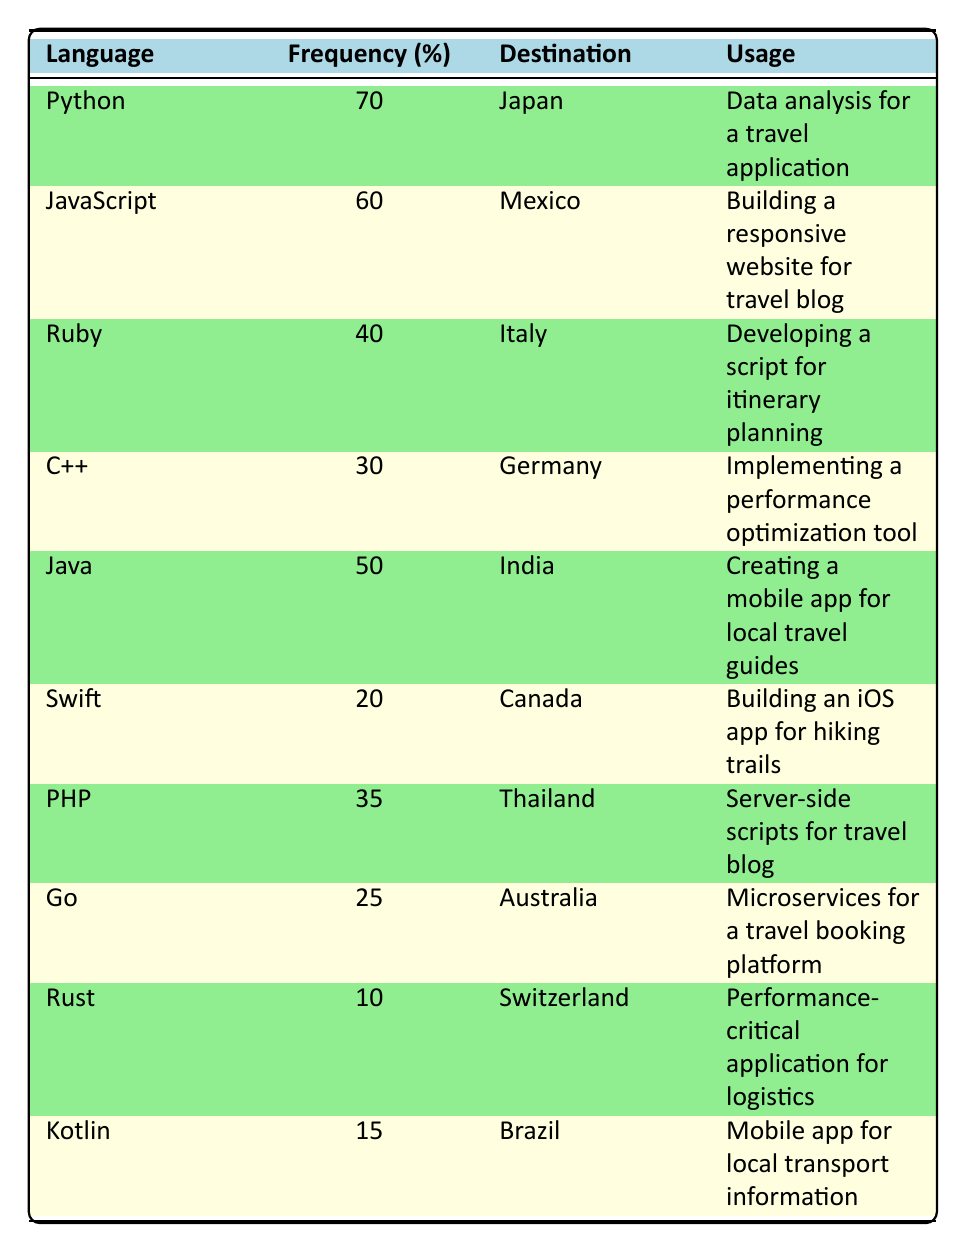What is the frequency of Python usage while traveling? The table lists Python with a frequency of use of 70%.
Answer: 70% Which programming language is used the least while traveling? Rust has the lowest frequency of use at 10%.
Answer: Rust What is the difference in frequency of use between Java and C++? Java has a frequency of 50%, while C++ has a frequency of 30%, so the difference is 50% - 30% = 20%.
Answer: 20% Does Ruby have a higher frequency of use than Go? Ruby has a frequency of 40%, while Go has a frequency of 25%, thus Ruby's frequency is higher.
Answer: Yes What is the average frequency of programming languages used in this data? The frequencies are 70, 60, 40, 30, 50, 20, 35, 25, 10, and 15. Summing these gives 70 + 60 + 40 + 30 + 50 + 20 + 35 + 25 + 10 + 15 =  415. Dividing by 10 (the number of languages) gives an average of 415 / 10 = 41.5.
Answer: 41.5 Which languages are used in destinations with a frequency above 30%? The languages with frequencies above 30% are Python (70%), JavaScript (60%), Ruby (40%), Java (50%), and PHP (35%).
Answer: Python, JavaScript, Ruby, Java, PHP Is there any programming language used for server-side scripts in Thailand based on this table? PHP is the language listed for server-side scripts used in Thailand.
Answer: Yes What is the total frequency of usage for languages used in Asia? The frequencies for languages used in Asia (Japan, India, Thailand) are 70 (Python), 50 (Java), and 35 (PHP). Adding these together gives 70 + 50 + 35 = 155.
Answer: 155 